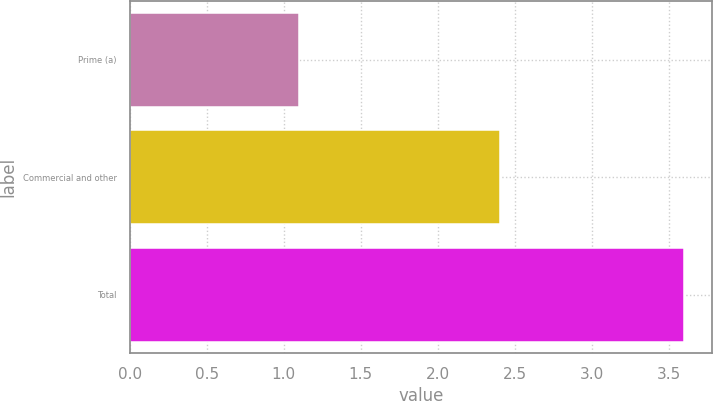Convert chart to OTSL. <chart><loc_0><loc_0><loc_500><loc_500><bar_chart><fcel>Prime (a)<fcel>Commercial and other<fcel>Total<nl><fcel>1.1<fcel>2.4<fcel>3.6<nl></chart> 